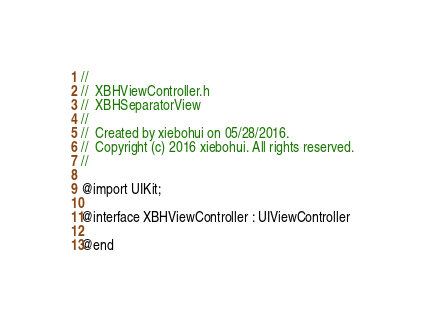<code> <loc_0><loc_0><loc_500><loc_500><_C_>//
//  XBHViewController.h
//  XBHSeparatorView
//
//  Created by xiebohui on 05/28/2016.
//  Copyright (c) 2016 xiebohui. All rights reserved.
//

@import UIKit;

@interface XBHViewController : UIViewController

@end
</code> 